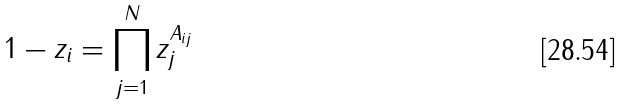Convert formula to latex. <formula><loc_0><loc_0><loc_500><loc_500>1 - z _ { i } = \prod _ { j = 1 } ^ { N } z _ { j } ^ { A _ { i j } }</formula> 